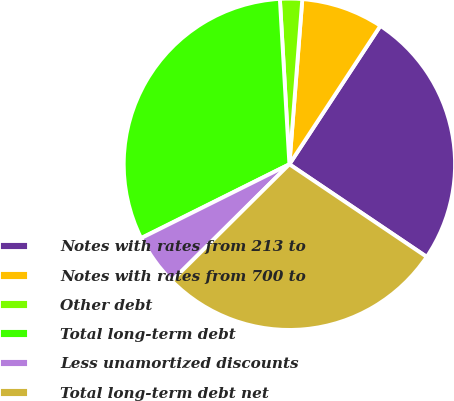Convert chart. <chart><loc_0><loc_0><loc_500><loc_500><pie_chart><fcel>Notes with rates from 213 to<fcel>Notes with rates from 700 to<fcel>Other debt<fcel>Total long-term debt<fcel>Less unamortized discounts<fcel>Total long-term debt net<nl><fcel>25.19%<fcel>8.01%<fcel>2.16%<fcel>31.44%<fcel>5.08%<fcel>28.12%<nl></chart> 